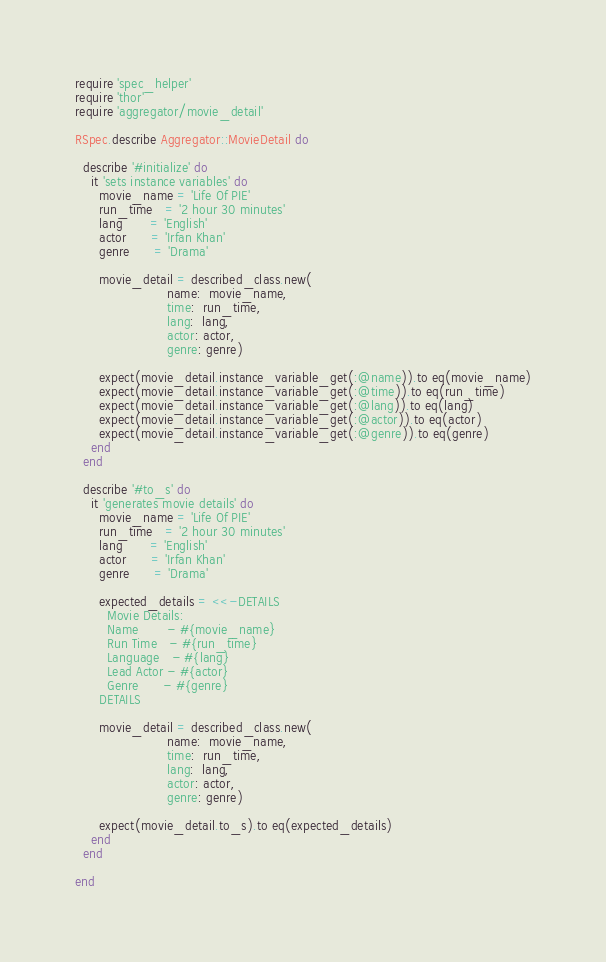<code> <loc_0><loc_0><loc_500><loc_500><_Ruby_>require 'spec_helper'
require 'thor'
require 'aggregator/movie_detail'

RSpec.describe Aggregator::MovieDetail do

  describe '#initialize' do
    it 'sets instance variables' do
      movie_name = 'Life Of PIE'
      run_time   = '2 hour 30 minutes'
      lang       = 'English'
      actor      = 'Irfan Khan'
      genre      = 'Drama'

      movie_detail = described_class.new(
                       name:  movie_name,
                       time:  run_time,
                       lang:  lang,
                       actor: actor,
                       genre: genre)

      expect(movie_detail.instance_variable_get(:@name)).to eq(movie_name)
      expect(movie_detail.instance_variable_get(:@time)).to eq(run_time)
      expect(movie_detail.instance_variable_get(:@lang)).to eq(lang)
      expect(movie_detail.instance_variable_get(:@actor)).to eq(actor)
      expect(movie_detail.instance_variable_get(:@genre)).to eq(genre)
    end
  end

  describe '#to_s' do
    it 'generates movie details' do
      movie_name = 'Life Of PIE'
      run_time   = '2 hour 30 minutes'
      lang       = 'English'
      actor      = 'Irfan Khan'
      genre      = 'Drama'

      expected_details = <<-DETAILS
        Movie Details:
        Name       - #{movie_name}
        Run Time   - #{run_time}
        Language   - #{lang}
        Lead Actor - #{actor}
        Genre      - #{genre}
      DETAILS

      movie_detail = described_class.new(
                       name:  movie_name,
                       time:  run_time,
                       lang:  lang,
                       actor: actor,
                       genre: genre)

      expect(movie_detail.to_s).to eq(expected_details)
    end
  end

end
</code> 